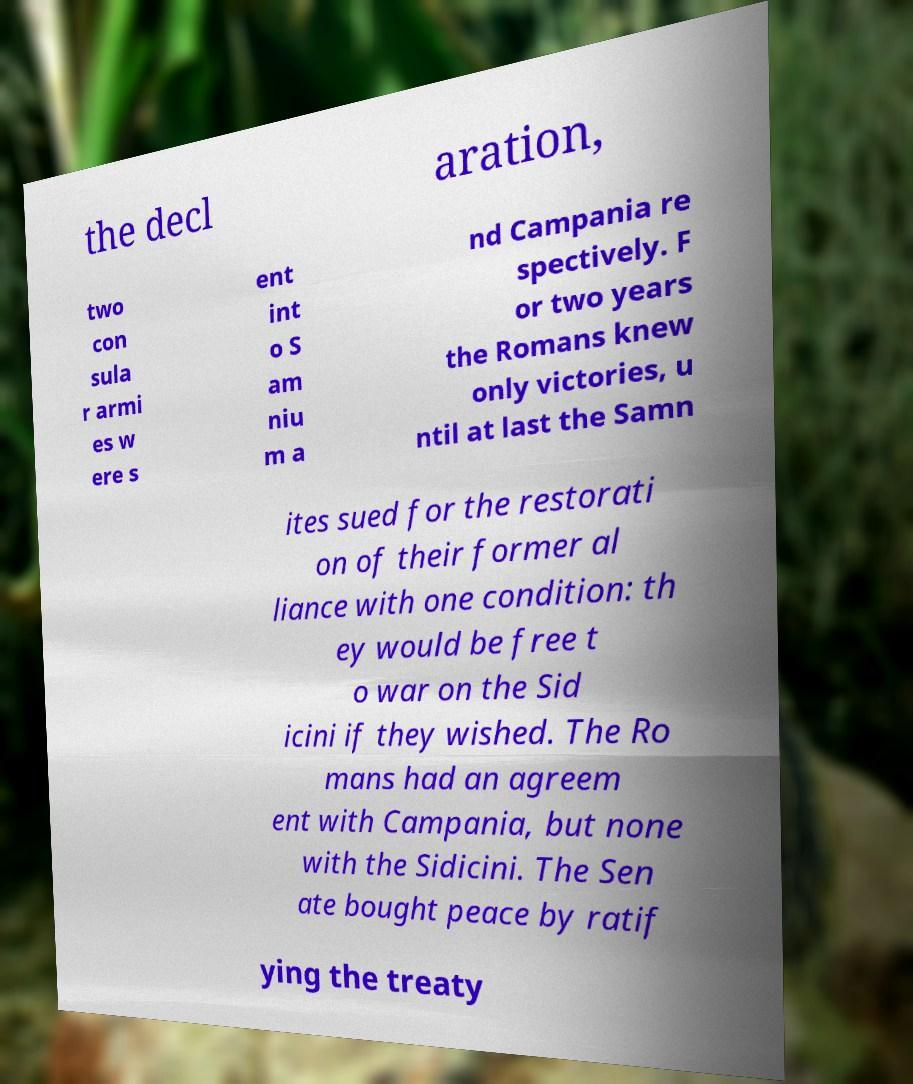Please read and relay the text visible in this image. What does it say? the decl aration, two con sula r armi es w ere s ent int o S am niu m a nd Campania re spectively. F or two years the Romans knew only victories, u ntil at last the Samn ites sued for the restorati on of their former al liance with one condition: th ey would be free t o war on the Sid icini if they wished. The Ro mans had an agreem ent with Campania, but none with the Sidicini. The Sen ate bought peace by ratif ying the treaty 